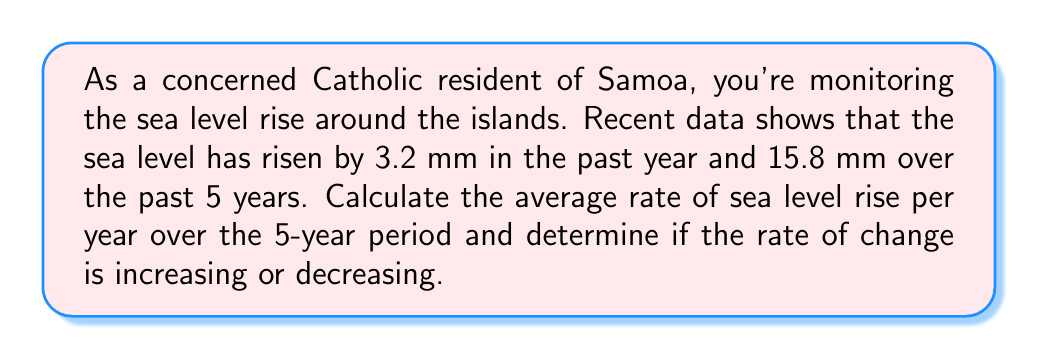Show me your answer to this math problem. To solve this problem, we need to follow these steps:

1. Calculate the average rate of sea level rise over the 5-year period:
   $$\text{Average rate} = \frac{\text{Total rise}}{\text{Time period}}$$
   $$\text{Average rate} = \frac{15.8 \text{ mm}}{5 \text{ years}} = 3.16 \text{ mm/year}$$

2. Compare the most recent year's rate to the 5-year average:
   Most recent year's rate: 3.2 mm/year
   5-year average rate: 3.16 mm/year

3. Determine if the rate is increasing or decreasing:
   Since the most recent year's rate (3.2 mm/year) is higher than the 5-year average (3.16 mm/year), we can conclude that the rate of sea level rise is increasing.

4. Calculate the difference in rates:
   $$\text{Difference} = \text{Recent rate} - \text{Average rate}$$
   $$\text{Difference} = 3.2 \text{ mm/year} - 3.16 \text{ mm/year} = 0.04 \text{ mm/year}$$

This difference represents the acceleration of sea level rise.
Answer: The average rate of sea level rise over the 5-year period is 3.16 mm/year. The rate of change is increasing, with an acceleration of 0.04 mm/year. 